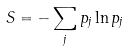<formula> <loc_0><loc_0><loc_500><loc_500>S = - \sum _ { j } p _ { j } \ln p _ { j }</formula> 